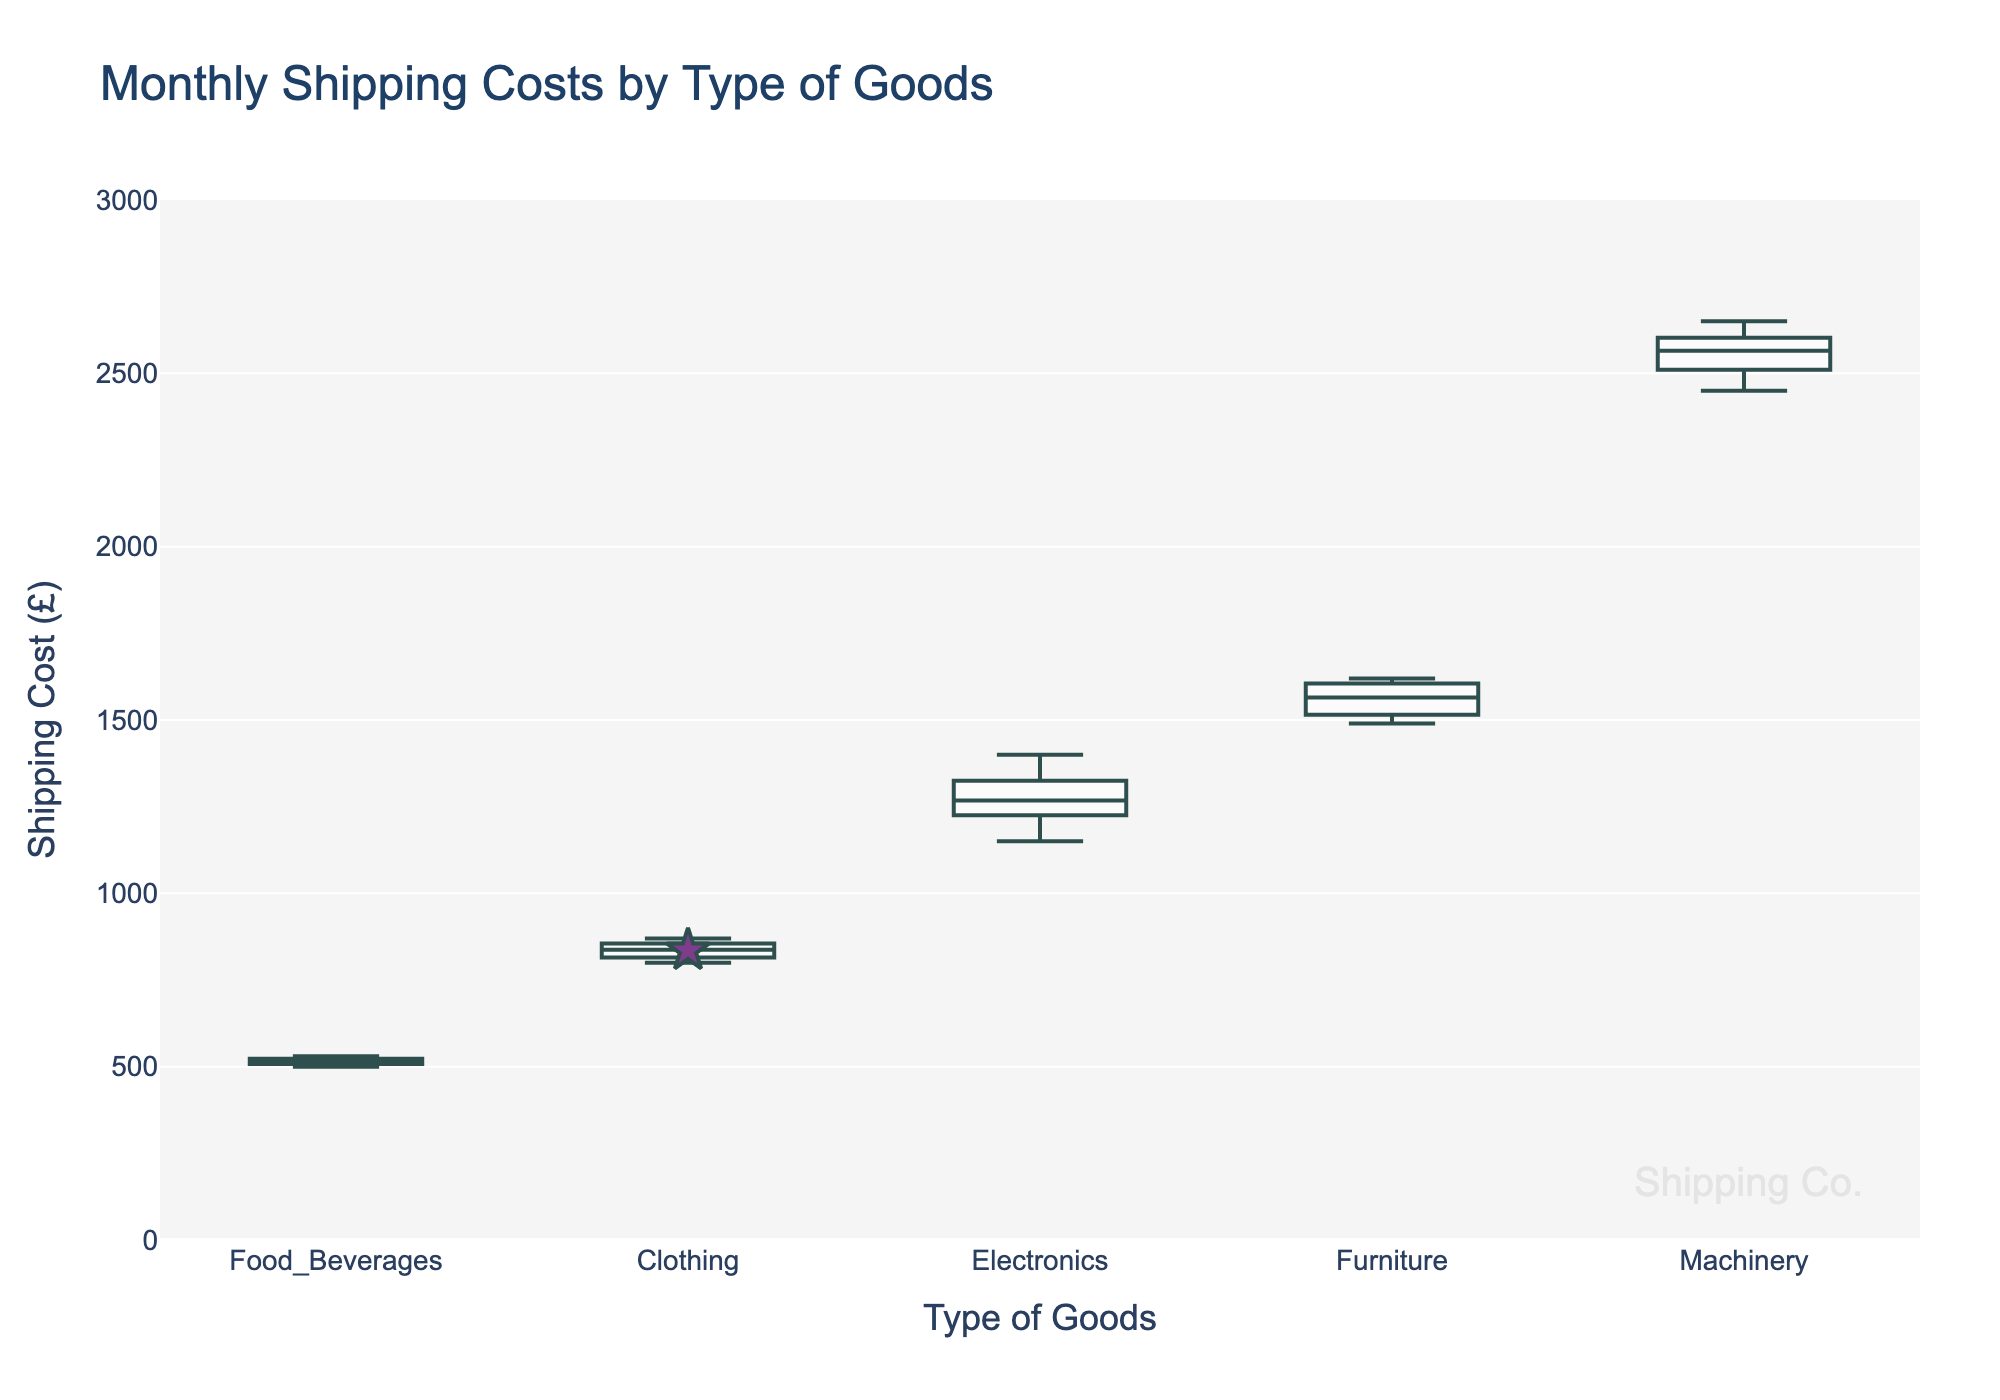What is the title of the box plot? The title is usually located at the top of the plot. It summarizes what the plot represents.
Answer: Monthly Shipping Costs by Type of Goods What are the labels for the x-axis and y-axis? The x-axis label is typically found along the horizontal axis, and the y-axis label is found along the vertical axis.
Answer: Type of Goods and Shipping Cost (£) Which type of goods has the highest median shipping cost? The median is represented by the line inside each box plot. By comparing the lines, we can find the one at the highest position.
Answer: Machinery Which type of goods has the smallest range in shipping costs? The range is represented by the length of the box (interquartile range) and the whiskers (minimum to maximum). The smallest range will have the shortest overall box and whiskers.
Answer: Food_Beverages What is the median shipping cost for Clothing? The median is represented by the line inside the box for Clothing.
Answer: 835 How do the shipping costs for Electronics compare to Furniture? By comparing the medians (lines inside the boxes) and the interquartile ranges (boxes' height) of both categories.
Answer: Electronics have lower medians and interquartile ranges compared to Furniture What is the interquartile range (IQR) for Furniture? The IQR is the length of the box in the box plot extending from the first quartile (bottom line of the box) to the third quartile (top line of the box).
Answer: 90 (1610-1520) Which type of goods has the broadest distribution of shipping costs? The broadest distribution can be identified by the length of the whiskers and the range of outliers.
Answer: Machinery What does the star symbol represent on the plot? The star symbol represents the mean shipping cost for each type of goods. This is indicated by a unique symbol that stands out from the rest of the plot.
Answer: Mean shipping cost What is the range of shipping costs for Clothing? The range is calculated by subtracting the minimum value (the bottom whisker) from the maximum value (the top whisker).
Answer: 60 (870-810) 